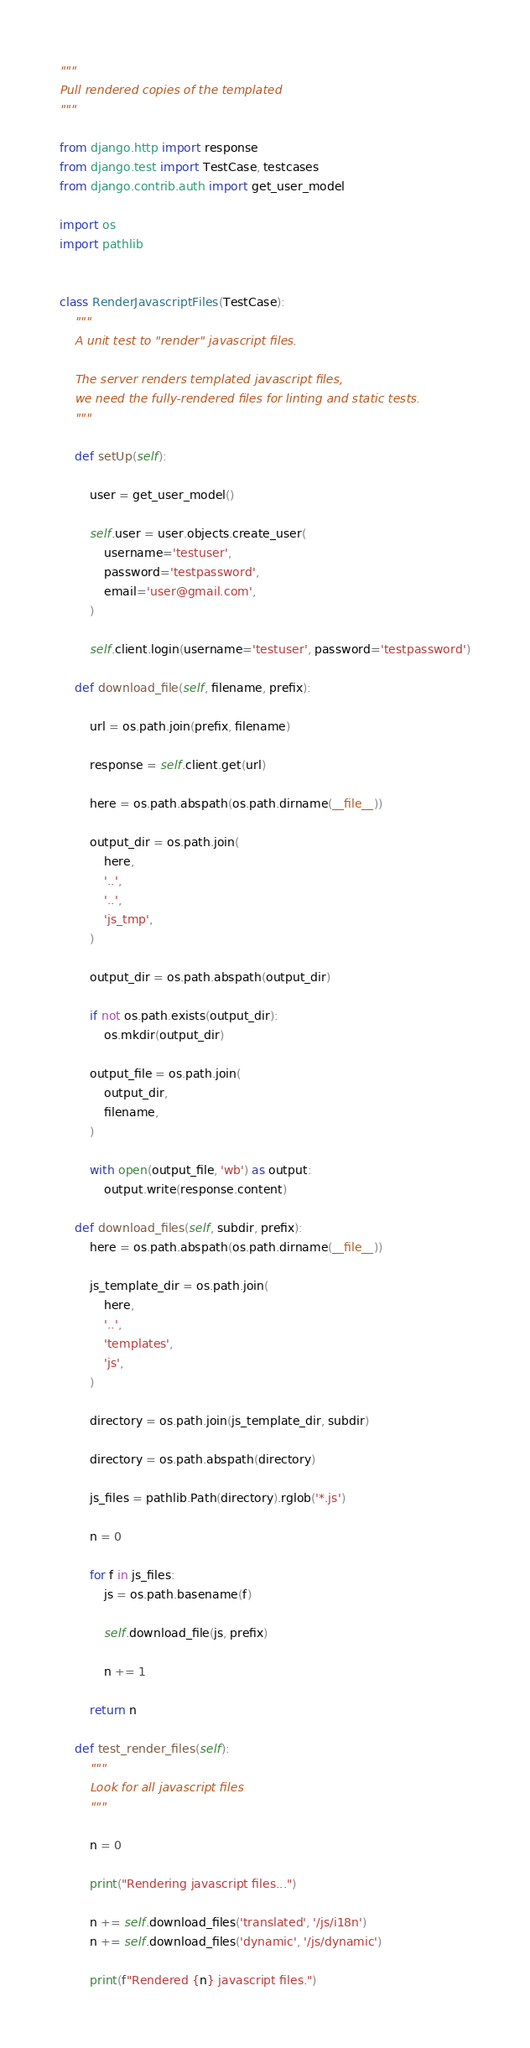<code> <loc_0><loc_0><loc_500><loc_500><_Python_>"""
Pull rendered copies of the templated 
"""

from django.http import response
from django.test import TestCase, testcases
from django.contrib.auth import get_user_model

import os
import pathlib


class RenderJavascriptFiles(TestCase):
    """
    A unit test to "render" javascript files.

    The server renders templated javascript files,
    we need the fully-rendered files for linting and static tests.
    """

    def setUp(self):

        user = get_user_model()

        self.user = user.objects.create_user(
            username='testuser',
            password='testpassword',
            email='user@gmail.com',
        )

        self.client.login(username='testuser', password='testpassword')

    def download_file(self, filename, prefix):

        url = os.path.join(prefix, filename)

        response = self.client.get(url)

        here = os.path.abspath(os.path.dirname(__file__))

        output_dir = os.path.join(
            here,
            '..',
            '..',
            'js_tmp',
        )

        output_dir = os.path.abspath(output_dir)

        if not os.path.exists(output_dir):
            os.mkdir(output_dir)

        output_file = os.path.join(
            output_dir,
            filename,
        )

        with open(output_file, 'wb') as output:
            output.write(response.content)

    def download_files(self, subdir, prefix):
        here = os.path.abspath(os.path.dirname(__file__))

        js_template_dir = os.path.join(
            here,
            '..',
            'templates',
            'js',
        )

        directory = os.path.join(js_template_dir, subdir)

        directory = os.path.abspath(directory)

        js_files = pathlib.Path(directory).rglob('*.js')

        n = 0

        for f in js_files:
            js = os.path.basename(f)

            self.download_file(js, prefix)

            n += 1

        return n

    def test_render_files(self):
        """
        Look for all javascript files
        """

        n = 0

        print("Rendering javascript files...")

        n += self.download_files('translated', '/js/i18n')
        n += self.download_files('dynamic', '/js/dynamic')

        print(f"Rendered {n} javascript files.")
</code> 